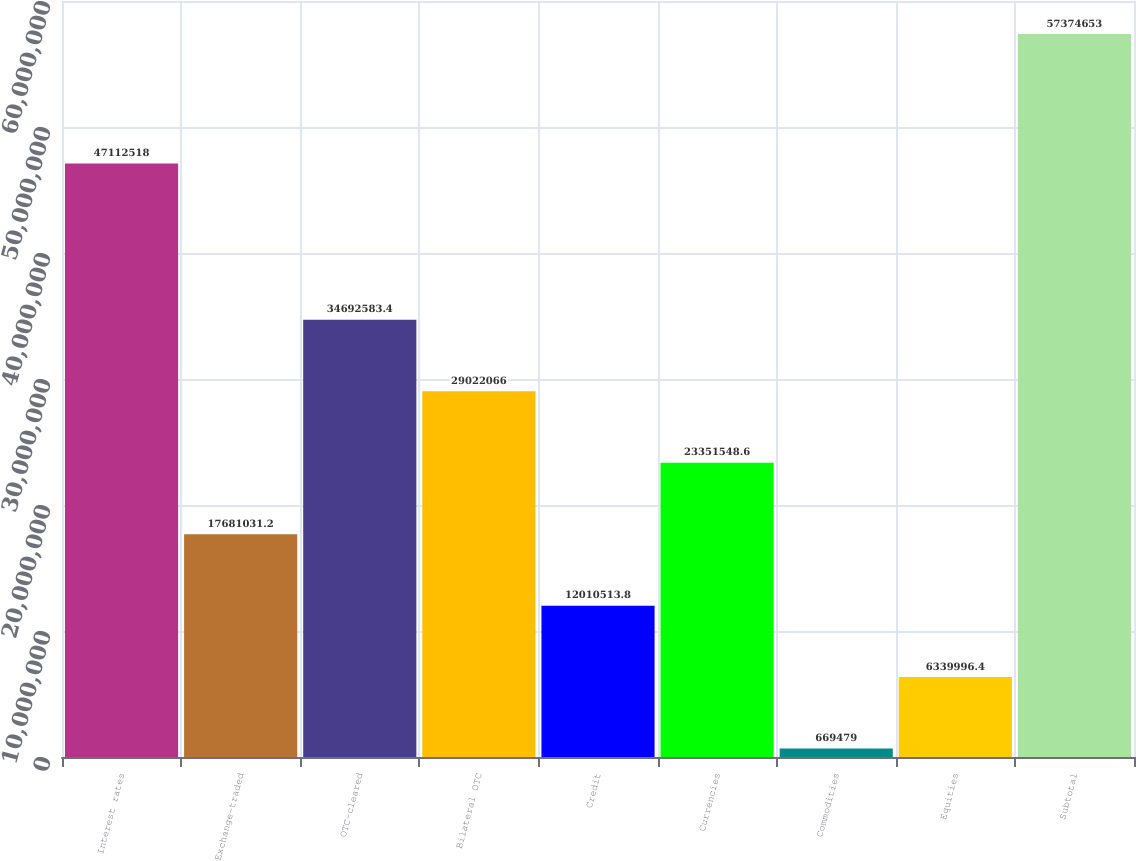Convert chart. <chart><loc_0><loc_0><loc_500><loc_500><bar_chart><fcel>Interest rates<fcel>Exchange-traded<fcel>OTC-cleared<fcel>Bilateral OTC<fcel>Credit<fcel>Currencies<fcel>Commodities<fcel>Equities<fcel>Subtotal<nl><fcel>4.71125e+07<fcel>1.7681e+07<fcel>3.46926e+07<fcel>2.90221e+07<fcel>1.20105e+07<fcel>2.33515e+07<fcel>669479<fcel>6.34e+06<fcel>5.73747e+07<nl></chart> 